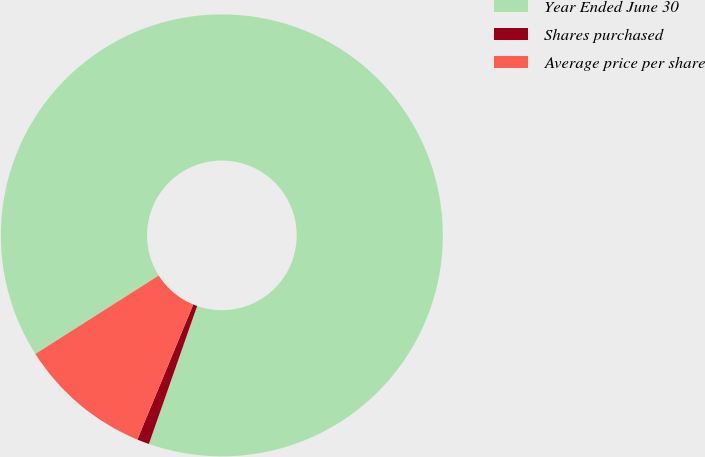Convert chart. <chart><loc_0><loc_0><loc_500><loc_500><pie_chart><fcel>Year Ended June 30<fcel>Shares purchased<fcel>Average price per share<nl><fcel>89.37%<fcel>0.89%<fcel>9.74%<nl></chart> 